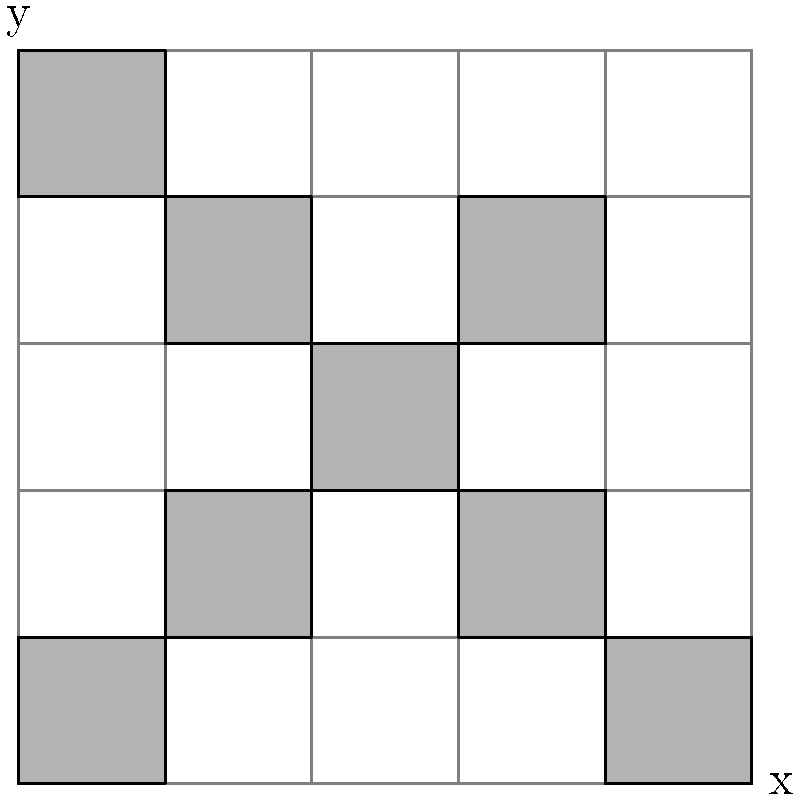In the satellite imagery of an urban area shown above, what type of geometric transformation would best describe the relationship between the two visible building patterns? To identify the relationship between the two building patterns, let's analyze the image step-by-step:

1. Observe the two distinct patterns:
   - Pattern A: A diagonal line of buildings from (0,0) to (4,4)
   - Pattern B: A diagonal line of buildings from (4,0) to (0,4)

2. Notice that both patterns form straight lines with the same length and slope magnitude.

3. The key difference is the direction of the slope:
   - Pattern A has a positive slope (bottom-left to top-right)
   - Pattern B has a negative slope (top-left to bottom-right)

4. This relationship suggests a reflection transformation.

5. To confirm, imagine a vertical line of reflection at x = 2.5 (the middle of the grid):
   - Each building in Pattern A would have a corresponding building in Pattern B equidistant from this line.

6. This reflection preserves the shape and size of the pattern while reversing its orientation.

Therefore, the geometric transformation that best describes the relationship between the two building patterns is a reflection across a vertical line.
Answer: Reflection 